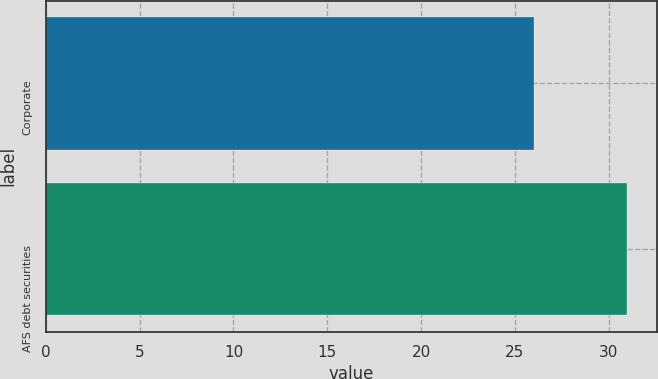Convert chart. <chart><loc_0><loc_0><loc_500><loc_500><bar_chart><fcel>Corporate<fcel>AFS debt securities<nl><fcel>26<fcel>31<nl></chart> 